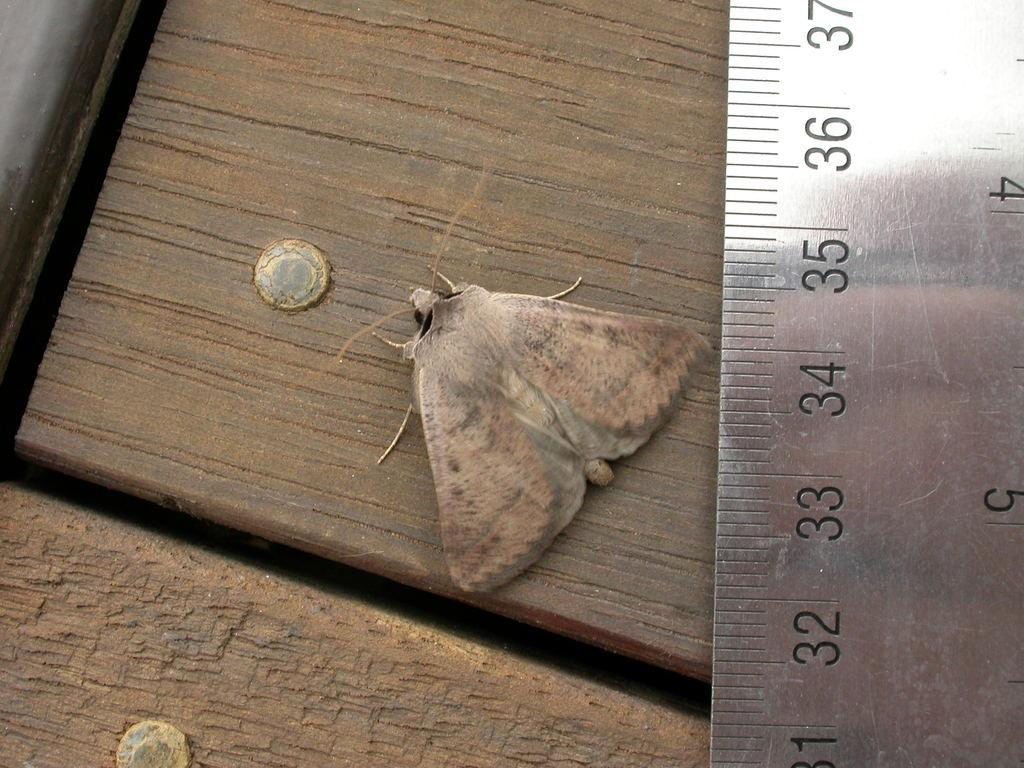<image>
Create a compact narrative representing the image presented. Small moth next to a silver ruler that has the number 34. 